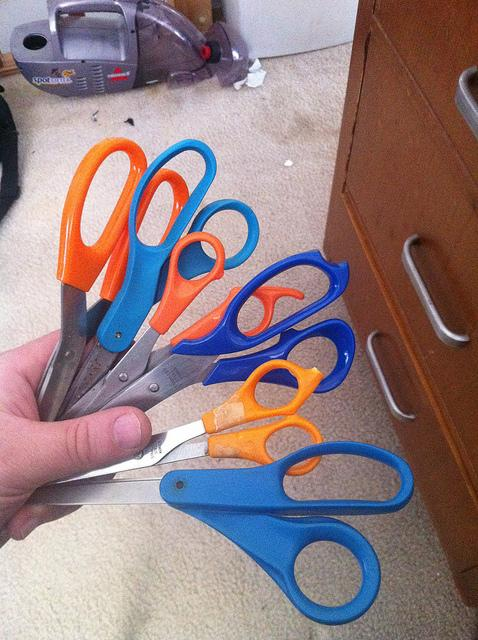What color is the smallest pair of scissors? Please explain your reasoning. orange. The color is orange. 